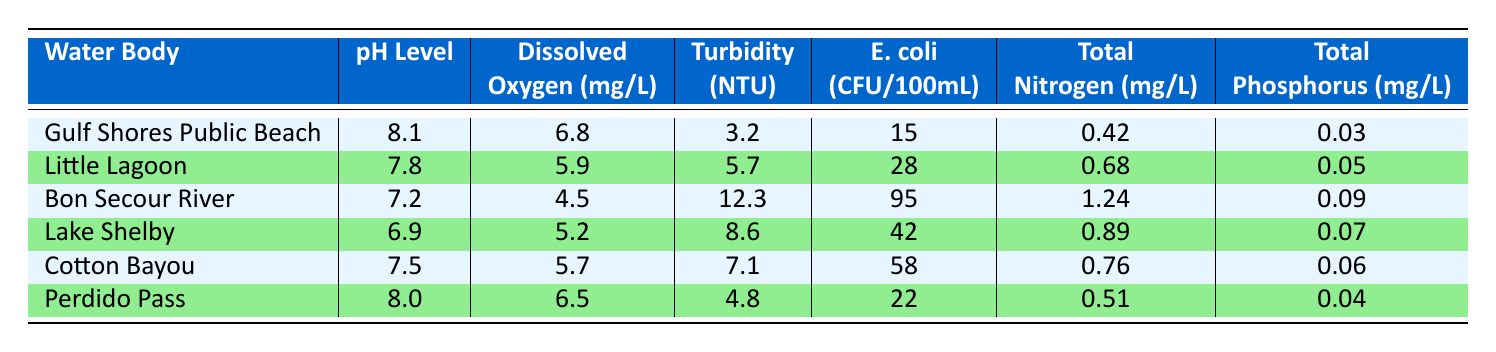What is the pH level of Gulf Shores Public Beach? The table lists the pH level of Gulf Shores Public Beach as 8.1.
Answer: 8.1 What is the highest recorded E. coli level among the water bodies? By checking the E. coli levels, I see Bon Secour River has the highest count at 95 CFU/100mL.
Answer: 95 Which water body has the lowest dissolved oxygen level? The dissolved oxygen levels show that Bon Secour River has the lowest at 4.5 mg/L.
Answer: 4.5 What is the average turbidity of Little Lagoon and Cotton Bayou? First, I find the turbidity levels: Little Lagoon is 5.7 NTU and Cotton Bayou is 7.1 NTU. Their average is (5.7 + 7.1) / 2 = 6.4 NTU.
Answer: 6.4 Is the dissolved oxygen level in Perdido Pass higher than in Lake Shelby? The dissolved oxygen in Perdido Pass is 6.5 mg/L and in Lake Shelby is 5.2 mg/L. Therefore, yes, it is higher.
Answer: Yes What is the total phosphorus level in Bon Secour River compared to Gulf Shores Public Beach? Bon Secour River has a total phosphorus of 0.09 mg/L, while Gulf Shores Public Beach has 0.03 mg/L. Since 0.09 is greater than 0.03, Bon Secour River's phosphorus level is higher.
Answer: Higher Which water body has the second highest total nitrogen level? The total nitrogen levels show that Little Lagoon (0.68 mg/L) has the second highest level, after Bon Secour River (1.24 mg/L).
Answer: Little Lagoon If we want to reduce E. coli levels to below 20 CFU/100mL, which two water bodies need the most attention? E. coli levels exceeding 20 include Bon Secour River (95), Lake Shelby (42), and Cotton Bayou (58). Focus on Bon Secour River and Cotton Bayou for the highest counts.
Answer: Bon Secour River and Cotton Bayou What is the difference in total nitrogen levels between Gulf Shores Public Beach and Cotton Bayou? Gulf Shores Public Beach has 0.42 mg/L of total nitrogen, while Cotton Bayou has 0.76 mg/L. The difference is 0.76 - 0.42 = 0.34 mg/L.
Answer: 0.34 